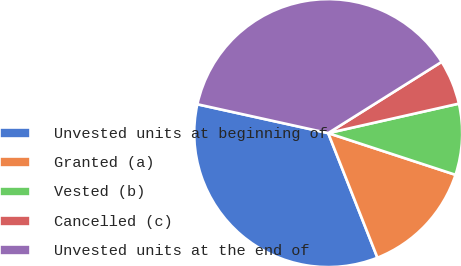Convert chart to OTSL. <chart><loc_0><loc_0><loc_500><loc_500><pie_chart><fcel>Unvested units at beginning of<fcel>Granted (a)<fcel>Vested (b)<fcel>Cancelled (c)<fcel>Unvested units at the end of<nl><fcel>34.44%<fcel>13.97%<fcel>8.57%<fcel>5.39%<fcel>37.62%<nl></chart> 